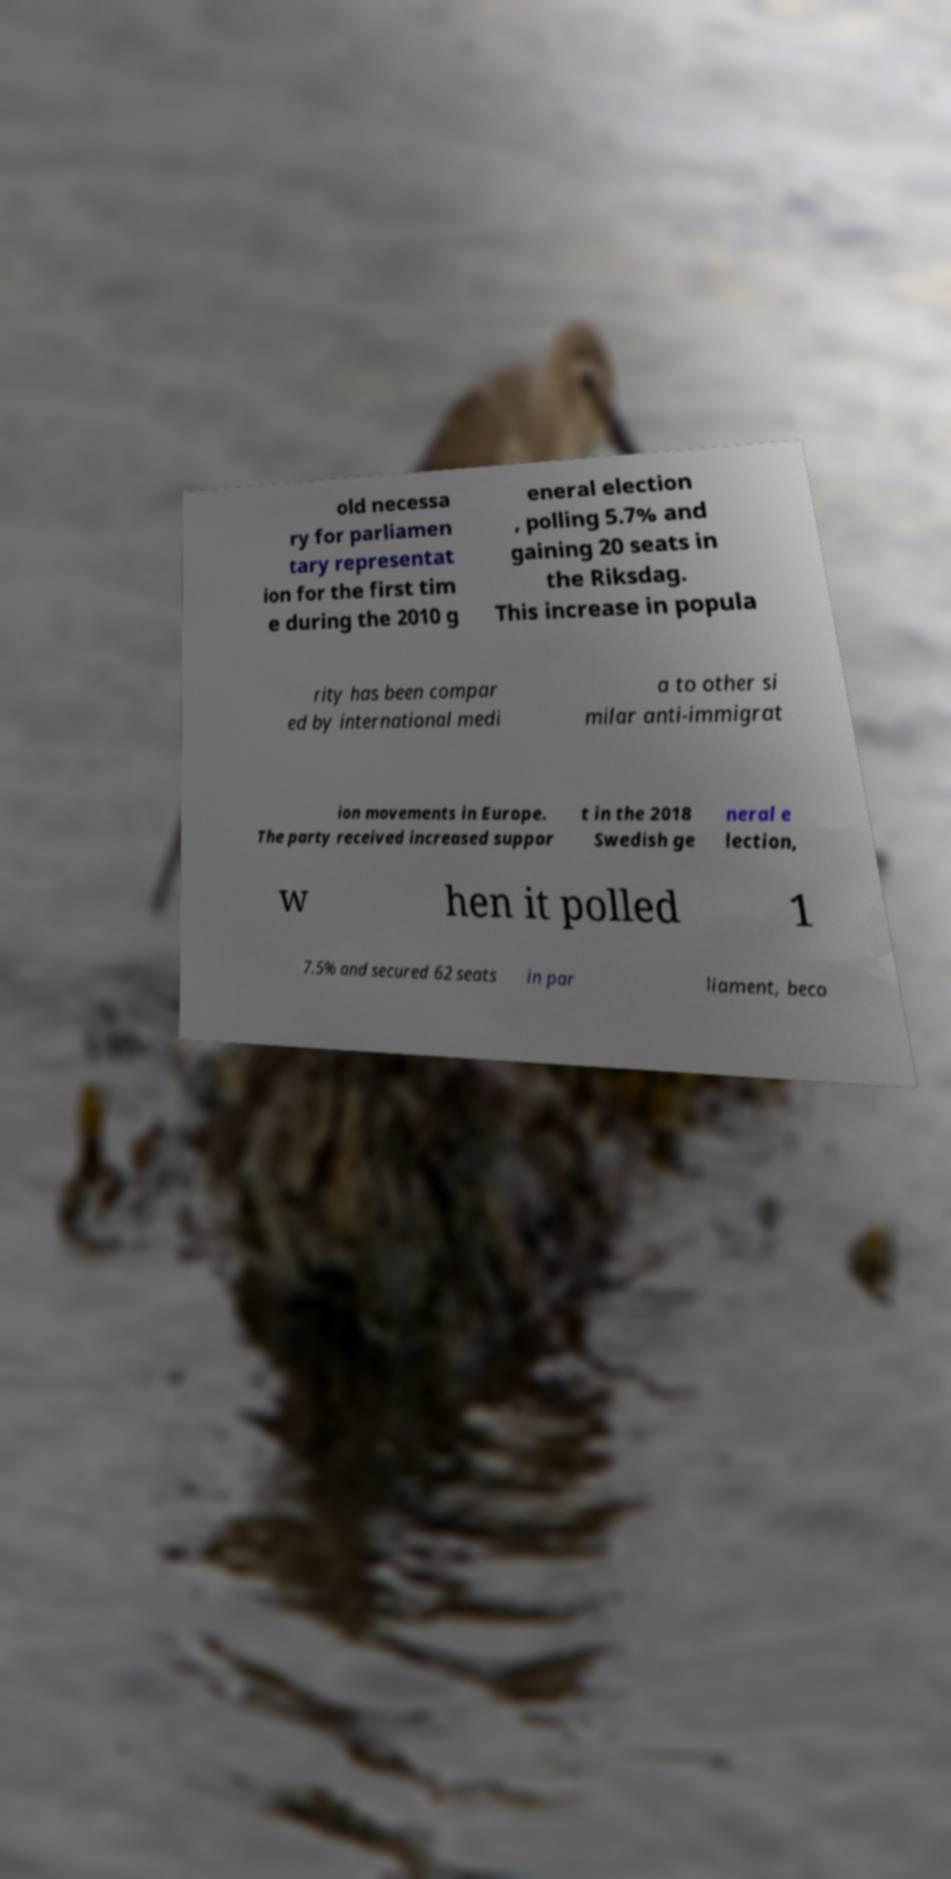Can you accurately transcribe the text from the provided image for me? old necessa ry for parliamen tary representat ion for the first tim e during the 2010 g eneral election , polling 5.7% and gaining 20 seats in the Riksdag. This increase in popula rity has been compar ed by international medi a to other si milar anti-immigrat ion movements in Europe. The party received increased suppor t in the 2018 Swedish ge neral e lection, w hen it polled 1 7.5% and secured 62 seats in par liament, beco 